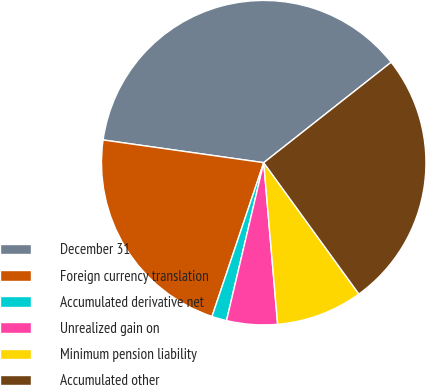Convert chart to OTSL. <chart><loc_0><loc_0><loc_500><loc_500><pie_chart><fcel>December 31<fcel>Foreign currency translation<fcel>Accumulated derivative net<fcel>Unrealized gain on<fcel>Minimum pension liability<fcel>Accumulated other<nl><fcel>37.14%<fcel>22.07%<fcel>1.48%<fcel>5.05%<fcel>8.61%<fcel>25.64%<nl></chart> 